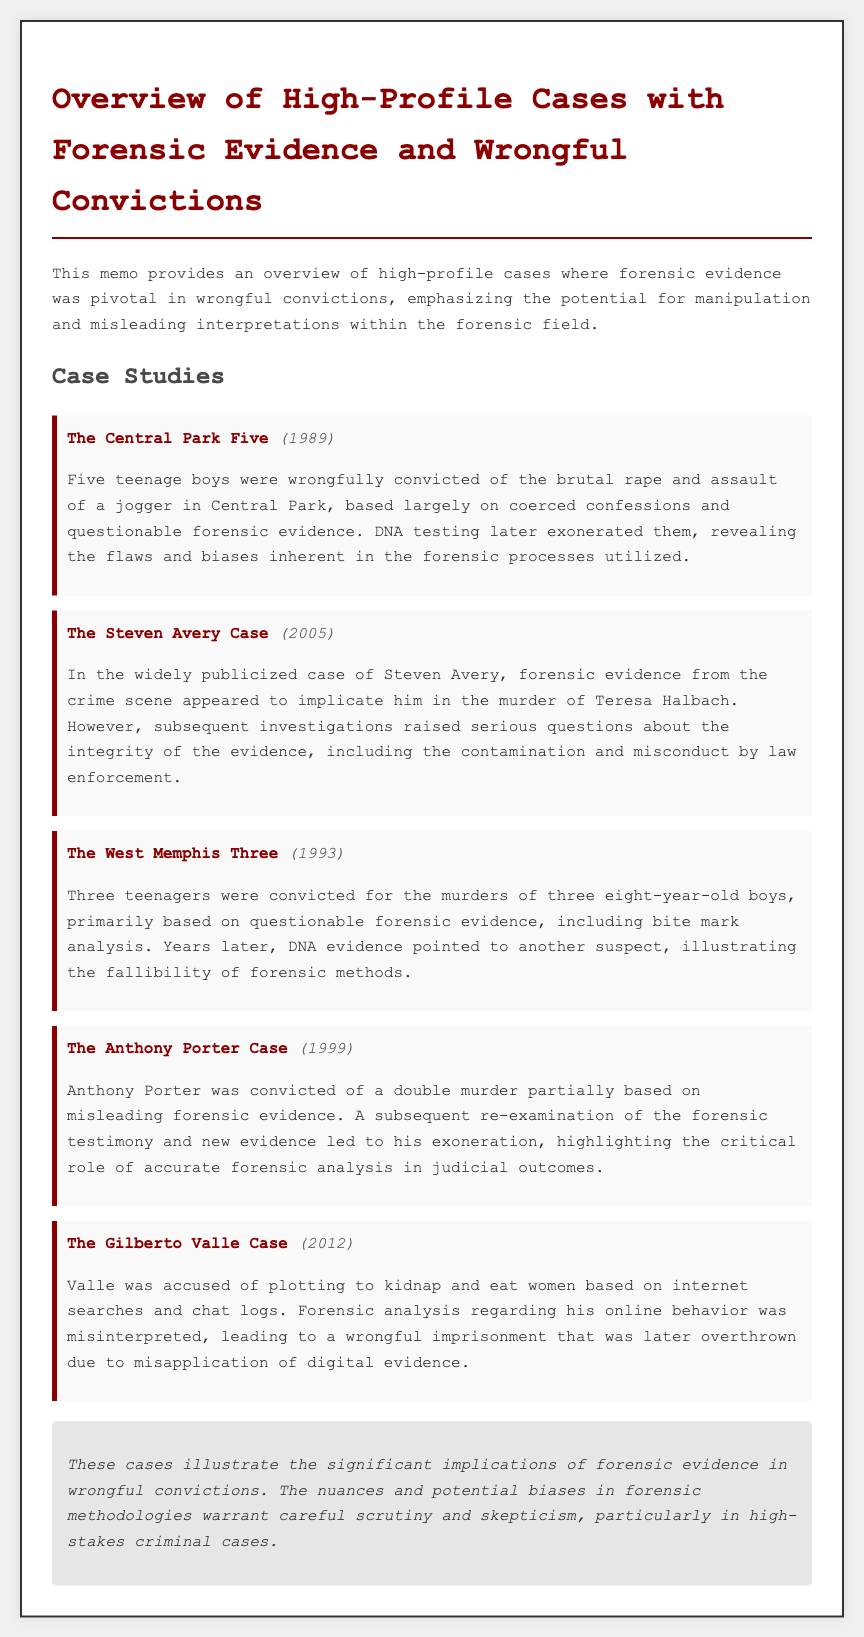What year did The Central Park Five case occur? The document states that The Central Park Five case occurred in 1989.
Answer: 1989 What type of evidence led to the conviction of Anthony Porter? The memo indicates that Anthony Porter was convicted partially based on misleading forensic evidence.
Answer: Misleading forensic evidence What was questioned in The Steven Avery Case? The document mentions that subsequent investigations raised serious questions about the integrity of the evidence.
Answer: Integrity of the evidence Which wrongful conviction case involved bite mark analysis? The document specifies that the West Memphis Three case involved questionable forensic evidence, including bite mark analysis.
Answer: West Memphis Three What conclusion does the memo make about forensic evidence? The conclusion highlights that the nuances and potential biases in forensic methodologies warrant careful scrutiny.
Answer: Careful scrutiny What was the outcome for The Gilberto Valle Case? The document notes that Valle's wrongful imprisonment was later overthrown due to misapplication of digital evidence.
Answer: Overthrown How many teenagers were wrongfully convicted in The West Memphis Three case? According to the memo, three teenagers were convicted.
Answer: Three teenagers What year was The Anthony Porter Case? The document states that The Anthony Porter Case occurred in 1999.
Answer: 1999 